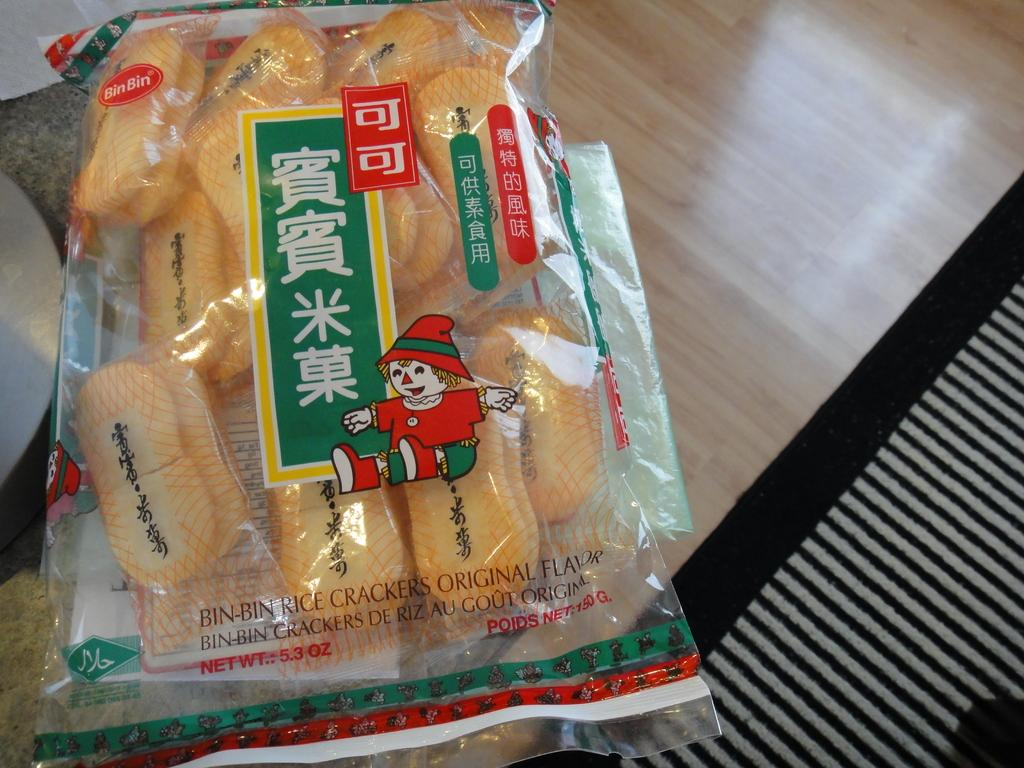What piece of furniture is present in the image? There is a table in the image. What is placed on the table? There is a food packet, papers, and cloth on the table. Can you describe the food packet? The food packet is a package containing food items. What might the papers on the table be used for? The papers on the table might be used for writing, drawing, or reading. How many basketball players are visible in the image? There are no basketball players present in the image. What color are the crayons on the table? There are no crayons present in the image. 